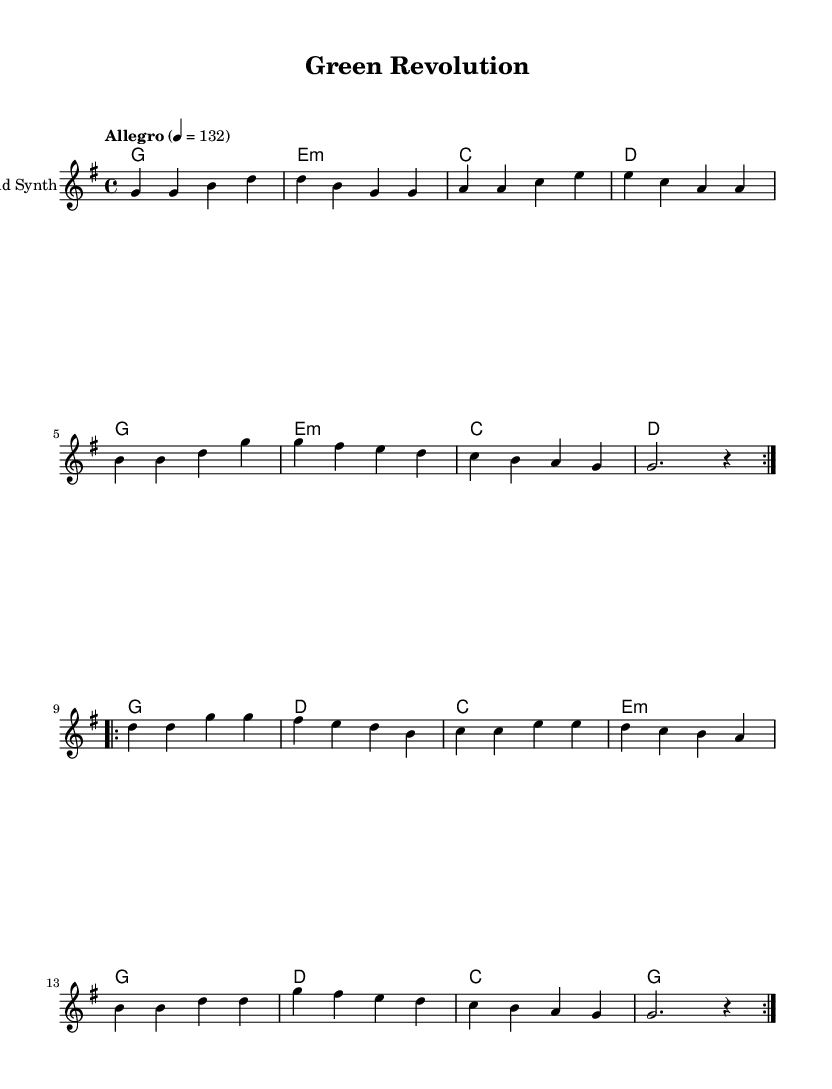What is the key signature of this music? The key signature is G major, which has one sharp (F#). This can be determined by looking at the key signature indicated at the beginning of the score, which shows one sharp.
Answer: G major What is the time signature of this music? The time signature is 4/4, as seen at the beginning of the score. This means there are four beats in each measure and the quarter note receives one beat.
Answer: 4/4 What is the tempo marking of this piece? The tempo marking is "Allegro" with a quarter note tempo of 132. This is noted just after the time signature, indicating the speed at which the piece should be played.
Answer: Allegro 4 = 132 How many measures are there in the repeated section of the melody? There are eight measures in the repeated section of the melody. Each of the two volta sections has four measures, and there are two repetitions indicated.
Answer: 8 measures Identify the primary chord used in the first harmony section. The primary chord used in the first harmony section is G major. It is the first chord listed in the chord progression and is repeated at the beginning of the first volta.
Answer: G What type of music is this score classified as? This score is classified as K-Pop, which typically features upbeat melodies, catchy hooks, and themes that resonate with youth culture, such as conservation in this context.
Answer: K-Pop How many times is the first melody section repeated? The first melody section is repeated two times as indicated by the "repeat volta" markings. This shows that the melody is meant to cycle through twice before proceeding.
Answer: 2 times 